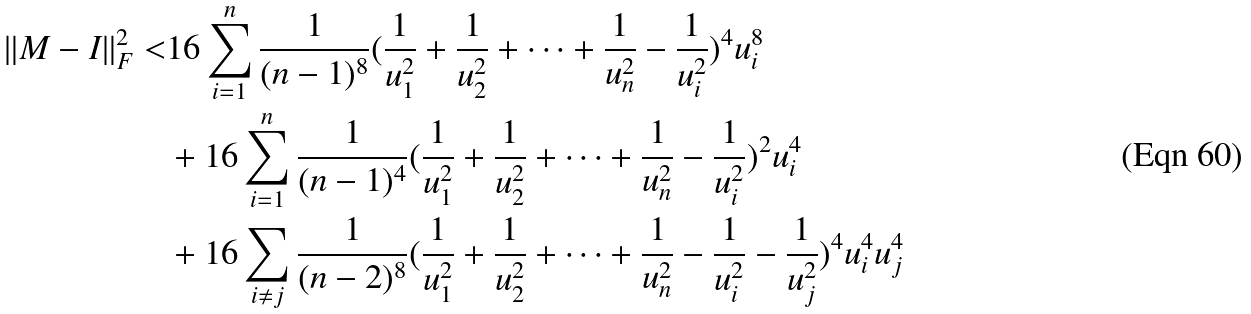Convert formula to latex. <formula><loc_0><loc_0><loc_500><loc_500>\| M - I \| _ { F } ^ { 2 } < & 1 6 \sum _ { i = 1 } ^ { n } \frac { 1 } { ( n - 1 ) ^ { 8 } } ( \frac { 1 } { u _ { 1 } ^ { 2 } } + \frac { 1 } { u _ { 2 } ^ { 2 } } + \dots + \frac { 1 } { u _ { n } ^ { 2 } } - \frac { 1 } { u _ { i } ^ { 2 } } ) ^ { 4 } u _ { i } ^ { 8 } \\ & + 1 6 \sum _ { i = 1 } ^ { n } \frac { 1 } { ( n - 1 ) ^ { 4 } } ( \frac { 1 } { u _ { 1 } ^ { 2 } } + \frac { 1 } { u _ { 2 } ^ { 2 } } + \dots + \frac { 1 } { u _ { n } ^ { 2 } } - \frac { 1 } { u _ { i } ^ { 2 } } ) ^ { 2 } u _ { i } ^ { 4 } \\ & + 1 6 \sum _ { i \neq j } \frac { 1 } { ( n - 2 ) ^ { 8 } } ( \frac { 1 } { u _ { 1 } ^ { 2 } } + \frac { 1 } { u _ { 2 } ^ { 2 } } + \dots + \frac { 1 } { u _ { n } ^ { 2 } } - \frac { 1 } { u _ { i } ^ { 2 } } - \frac { 1 } { u _ { j } ^ { 2 } } ) ^ { 4 } u _ { i } ^ { 4 } u _ { j } ^ { 4 }</formula> 